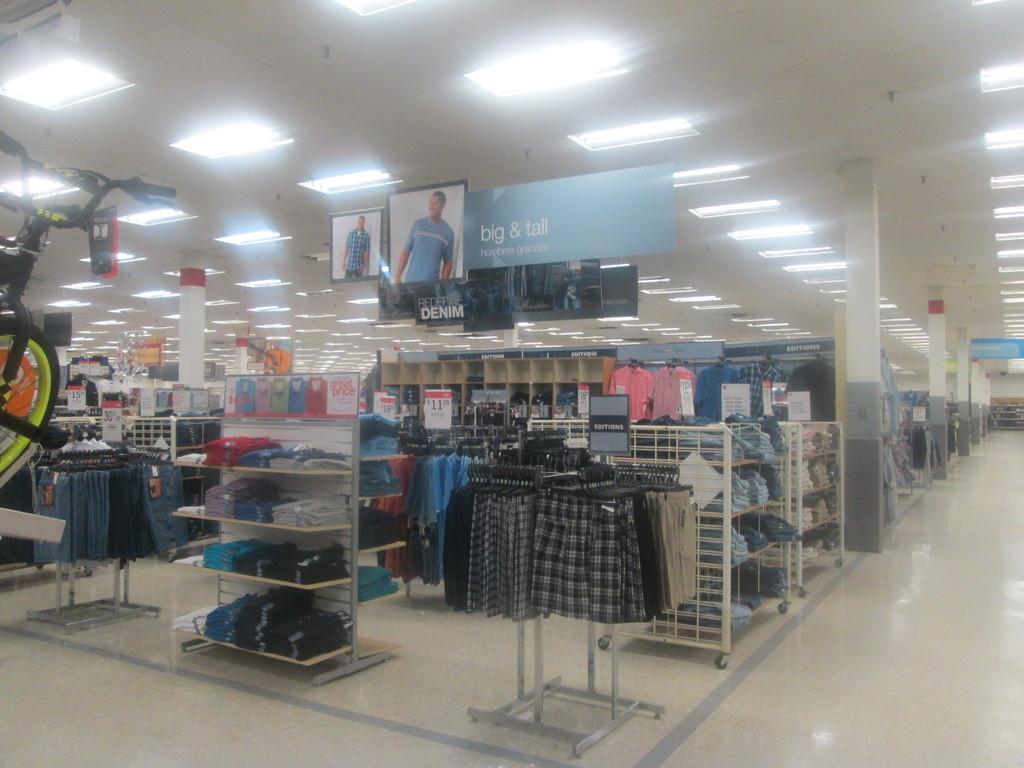Is there denim in this section?
Ensure brevity in your answer.  Yes. 